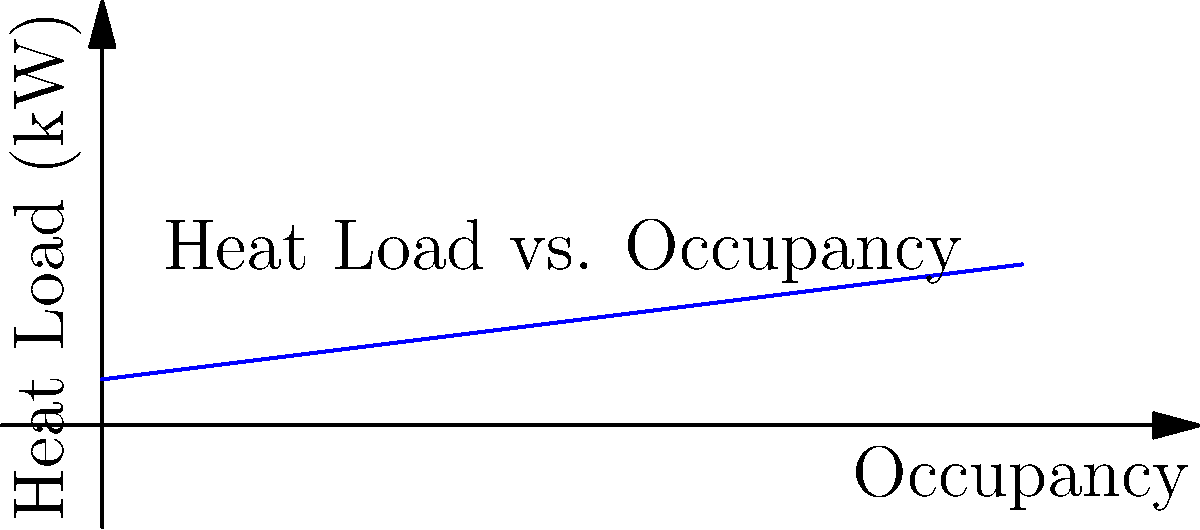As a software engineer developing applications for convention management, you're tasked with creating a module to calculate the required HVAC capacity for a convention hall. Given the heat load diagram above and assuming a maximum occupancy of 800 people, what would be the total heat load (in kW) for the convention hall? Additionally, if the HVAC system needs to be designed with a 20% safety factor, what should be the final HVAC capacity? To solve this problem, we'll follow these steps:

1. Interpret the graph:
   The graph shows the relationship between occupancy and heat load.

2. Determine the heat load for 800 people:
   At 800 people occupancy, the heat load is approximately 150 kW.

3. Apply the safety factor:
   The HVAC system needs to be designed with a 20% safety factor.
   
   Let's calculate the final HVAC capacity:
   $$\text{Final Capacity} = \text{Heat Load} \times (1 + \text{Safety Factor})$$
   $$\text{Final Capacity} = 150 \text{ kW} \times (1 + 0.20)$$
   $$\text{Final Capacity} = 150 \text{ kW} \times 1.20$$
   $$\text{Final Capacity} = 180 \text{ kW}$$

Therefore, the final HVAC capacity should be 180 kW to accommodate the maximum occupancy with the required safety factor.
Answer: 180 kW 